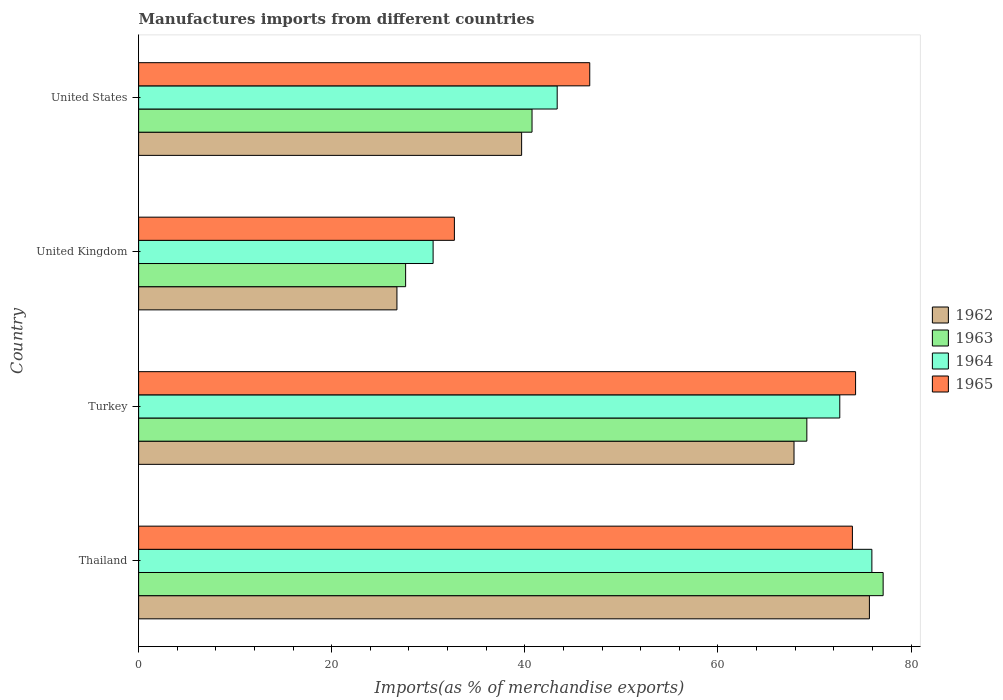How many groups of bars are there?
Your response must be concise. 4. How many bars are there on the 3rd tick from the top?
Provide a short and direct response. 4. In how many cases, is the number of bars for a given country not equal to the number of legend labels?
Keep it short and to the point. 0. What is the percentage of imports to different countries in 1962 in Thailand?
Give a very brief answer. 75.69. Across all countries, what is the maximum percentage of imports to different countries in 1964?
Offer a terse response. 75.95. Across all countries, what is the minimum percentage of imports to different countries in 1965?
Your response must be concise. 32.71. In which country was the percentage of imports to different countries in 1963 maximum?
Ensure brevity in your answer.  Thailand. In which country was the percentage of imports to different countries in 1964 minimum?
Make the answer very short. United Kingdom. What is the total percentage of imports to different countries in 1965 in the graph?
Your answer should be compact. 227.63. What is the difference between the percentage of imports to different countries in 1964 in Turkey and that in United Kingdom?
Your answer should be very brief. 42.12. What is the difference between the percentage of imports to different countries in 1962 in United States and the percentage of imports to different countries in 1963 in United Kingdom?
Your answer should be very brief. 12.01. What is the average percentage of imports to different countries in 1962 per country?
Your response must be concise. 52.5. What is the difference between the percentage of imports to different countries in 1962 and percentage of imports to different countries in 1963 in United Kingdom?
Ensure brevity in your answer.  -0.9. What is the ratio of the percentage of imports to different countries in 1964 in Thailand to that in United States?
Provide a short and direct response. 1.75. Is the difference between the percentage of imports to different countries in 1962 in Turkey and United Kingdom greater than the difference between the percentage of imports to different countries in 1963 in Turkey and United Kingdom?
Provide a succinct answer. No. What is the difference between the highest and the second highest percentage of imports to different countries in 1964?
Provide a succinct answer. 3.33. What is the difference between the highest and the lowest percentage of imports to different countries in 1965?
Provide a succinct answer. 41.55. Is the sum of the percentage of imports to different countries in 1965 in Thailand and United Kingdom greater than the maximum percentage of imports to different countries in 1964 across all countries?
Ensure brevity in your answer.  Yes. What does the 3rd bar from the top in United States represents?
Offer a terse response. 1963. How many countries are there in the graph?
Provide a succinct answer. 4. What is the difference between two consecutive major ticks on the X-axis?
Offer a very short reply. 20. Are the values on the major ticks of X-axis written in scientific E-notation?
Keep it short and to the point. No. Does the graph contain any zero values?
Offer a very short reply. No. How many legend labels are there?
Provide a short and direct response. 4. How are the legend labels stacked?
Offer a terse response. Vertical. What is the title of the graph?
Provide a succinct answer. Manufactures imports from different countries. Does "2004" appear as one of the legend labels in the graph?
Make the answer very short. No. What is the label or title of the X-axis?
Make the answer very short. Imports(as % of merchandise exports). What is the label or title of the Y-axis?
Offer a very short reply. Country. What is the Imports(as % of merchandise exports) of 1962 in Thailand?
Keep it short and to the point. 75.69. What is the Imports(as % of merchandise exports) in 1963 in Thailand?
Make the answer very short. 77.12. What is the Imports(as % of merchandise exports) in 1964 in Thailand?
Ensure brevity in your answer.  75.95. What is the Imports(as % of merchandise exports) in 1965 in Thailand?
Provide a succinct answer. 73.93. What is the Imports(as % of merchandise exports) of 1962 in Turkey?
Make the answer very short. 67.88. What is the Imports(as % of merchandise exports) in 1963 in Turkey?
Offer a very short reply. 69.21. What is the Imports(as % of merchandise exports) of 1964 in Turkey?
Offer a very short reply. 72.62. What is the Imports(as % of merchandise exports) of 1965 in Turkey?
Your response must be concise. 74.26. What is the Imports(as % of merchandise exports) in 1962 in United Kingdom?
Keep it short and to the point. 26.76. What is the Imports(as % of merchandise exports) in 1963 in United Kingdom?
Your answer should be very brief. 27.66. What is the Imports(as % of merchandise exports) of 1964 in United Kingdom?
Your answer should be compact. 30.5. What is the Imports(as % of merchandise exports) of 1965 in United Kingdom?
Offer a very short reply. 32.71. What is the Imports(as % of merchandise exports) in 1962 in United States?
Your answer should be very brief. 39.67. What is the Imports(as % of merchandise exports) of 1963 in United States?
Make the answer very short. 40.75. What is the Imports(as % of merchandise exports) of 1964 in United States?
Your response must be concise. 43.35. What is the Imports(as % of merchandise exports) of 1965 in United States?
Provide a short and direct response. 46.73. Across all countries, what is the maximum Imports(as % of merchandise exports) in 1962?
Your answer should be very brief. 75.69. Across all countries, what is the maximum Imports(as % of merchandise exports) in 1963?
Make the answer very short. 77.12. Across all countries, what is the maximum Imports(as % of merchandise exports) of 1964?
Offer a terse response. 75.95. Across all countries, what is the maximum Imports(as % of merchandise exports) of 1965?
Provide a succinct answer. 74.26. Across all countries, what is the minimum Imports(as % of merchandise exports) of 1962?
Ensure brevity in your answer.  26.76. Across all countries, what is the minimum Imports(as % of merchandise exports) of 1963?
Keep it short and to the point. 27.66. Across all countries, what is the minimum Imports(as % of merchandise exports) of 1964?
Offer a terse response. 30.5. Across all countries, what is the minimum Imports(as % of merchandise exports) of 1965?
Offer a terse response. 32.71. What is the total Imports(as % of merchandise exports) in 1962 in the graph?
Offer a terse response. 210. What is the total Imports(as % of merchandise exports) in 1963 in the graph?
Your response must be concise. 214.73. What is the total Imports(as % of merchandise exports) in 1964 in the graph?
Keep it short and to the point. 222.43. What is the total Imports(as % of merchandise exports) in 1965 in the graph?
Make the answer very short. 227.63. What is the difference between the Imports(as % of merchandise exports) of 1962 in Thailand and that in Turkey?
Your answer should be compact. 7.81. What is the difference between the Imports(as % of merchandise exports) of 1963 in Thailand and that in Turkey?
Your response must be concise. 7.9. What is the difference between the Imports(as % of merchandise exports) of 1964 in Thailand and that in Turkey?
Make the answer very short. 3.33. What is the difference between the Imports(as % of merchandise exports) of 1965 in Thailand and that in Turkey?
Keep it short and to the point. -0.33. What is the difference between the Imports(as % of merchandise exports) of 1962 in Thailand and that in United Kingdom?
Make the answer very short. 48.94. What is the difference between the Imports(as % of merchandise exports) of 1963 in Thailand and that in United Kingdom?
Offer a very short reply. 49.46. What is the difference between the Imports(as % of merchandise exports) of 1964 in Thailand and that in United Kingdom?
Provide a succinct answer. 45.45. What is the difference between the Imports(as % of merchandise exports) in 1965 in Thailand and that in United Kingdom?
Your answer should be compact. 41.22. What is the difference between the Imports(as % of merchandise exports) in 1962 in Thailand and that in United States?
Make the answer very short. 36.02. What is the difference between the Imports(as % of merchandise exports) of 1963 in Thailand and that in United States?
Provide a succinct answer. 36.37. What is the difference between the Imports(as % of merchandise exports) of 1964 in Thailand and that in United States?
Ensure brevity in your answer.  32.6. What is the difference between the Imports(as % of merchandise exports) in 1965 in Thailand and that in United States?
Give a very brief answer. 27.2. What is the difference between the Imports(as % of merchandise exports) in 1962 in Turkey and that in United Kingdom?
Your response must be concise. 41.13. What is the difference between the Imports(as % of merchandise exports) of 1963 in Turkey and that in United Kingdom?
Your answer should be compact. 41.56. What is the difference between the Imports(as % of merchandise exports) in 1964 in Turkey and that in United Kingdom?
Provide a succinct answer. 42.12. What is the difference between the Imports(as % of merchandise exports) of 1965 in Turkey and that in United Kingdom?
Give a very brief answer. 41.55. What is the difference between the Imports(as % of merchandise exports) of 1962 in Turkey and that in United States?
Your answer should be compact. 28.21. What is the difference between the Imports(as % of merchandise exports) of 1963 in Turkey and that in United States?
Offer a terse response. 28.47. What is the difference between the Imports(as % of merchandise exports) in 1964 in Turkey and that in United States?
Make the answer very short. 29.27. What is the difference between the Imports(as % of merchandise exports) of 1965 in Turkey and that in United States?
Make the answer very short. 27.53. What is the difference between the Imports(as % of merchandise exports) of 1962 in United Kingdom and that in United States?
Ensure brevity in your answer.  -12.91. What is the difference between the Imports(as % of merchandise exports) in 1963 in United Kingdom and that in United States?
Make the answer very short. -13.09. What is the difference between the Imports(as % of merchandise exports) in 1964 in United Kingdom and that in United States?
Your answer should be compact. -12.85. What is the difference between the Imports(as % of merchandise exports) of 1965 in United Kingdom and that in United States?
Ensure brevity in your answer.  -14.02. What is the difference between the Imports(as % of merchandise exports) in 1962 in Thailand and the Imports(as % of merchandise exports) in 1963 in Turkey?
Provide a short and direct response. 6.48. What is the difference between the Imports(as % of merchandise exports) in 1962 in Thailand and the Imports(as % of merchandise exports) in 1964 in Turkey?
Your response must be concise. 3.07. What is the difference between the Imports(as % of merchandise exports) in 1962 in Thailand and the Imports(as % of merchandise exports) in 1965 in Turkey?
Provide a short and direct response. 1.43. What is the difference between the Imports(as % of merchandise exports) of 1963 in Thailand and the Imports(as % of merchandise exports) of 1964 in Turkey?
Your response must be concise. 4.49. What is the difference between the Imports(as % of merchandise exports) in 1963 in Thailand and the Imports(as % of merchandise exports) in 1965 in Turkey?
Offer a terse response. 2.85. What is the difference between the Imports(as % of merchandise exports) in 1964 in Thailand and the Imports(as % of merchandise exports) in 1965 in Turkey?
Give a very brief answer. 1.69. What is the difference between the Imports(as % of merchandise exports) in 1962 in Thailand and the Imports(as % of merchandise exports) in 1963 in United Kingdom?
Your answer should be compact. 48.04. What is the difference between the Imports(as % of merchandise exports) of 1962 in Thailand and the Imports(as % of merchandise exports) of 1964 in United Kingdom?
Make the answer very short. 45.19. What is the difference between the Imports(as % of merchandise exports) in 1962 in Thailand and the Imports(as % of merchandise exports) in 1965 in United Kingdom?
Your answer should be very brief. 42.99. What is the difference between the Imports(as % of merchandise exports) of 1963 in Thailand and the Imports(as % of merchandise exports) of 1964 in United Kingdom?
Your answer should be very brief. 46.61. What is the difference between the Imports(as % of merchandise exports) in 1963 in Thailand and the Imports(as % of merchandise exports) in 1965 in United Kingdom?
Give a very brief answer. 44.41. What is the difference between the Imports(as % of merchandise exports) in 1964 in Thailand and the Imports(as % of merchandise exports) in 1965 in United Kingdom?
Your answer should be very brief. 43.24. What is the difference between the Imports(as % of merchandise exports) of 1962 in Thailand and the Imports(as % of merchandise exports) of 1963 in United States?
Ensure brevity in your answer.  34.95. What is the difference between the Imports(as % of merchandise exports) of 1962 in Thailand and the Imports(as % of merchandise exports) of 1964 in United States?
Make the answer very short. 32.34. What is the difference between the Imports(as % of merchandise exports) in 1962 in Thailand and the Imports(as % of merchandise exports) in 1965 in United States?
Offer a terse response. 28.97. What is the difference between the Imports(as % of merchandise exports) in 1963 in Thailand and the Imports(as % of merchandise exports) in 1964 in United States?
Your answer should be very brief. 33.76. What is the difference between the Imports(as % of merchandise exports) in 1963 in Thailand and the Imports(as % of merchandise exports) in 1965 in United States?
Give a very brief answer. 30.39. What is the difference between the Imports(as % of merchandise exports) in 1964 in Thailand and the Imports(as % of merchandise exports) in 1965 in United States?
Provide a short and direct response. 29.22. What is the difference between the Imports(as % of merchandise exports) of 1962 in Turkey and the Imports(as % of merchandise exports) of 1963 in United Kingdom?
Your answer should be very brief. 40.23. What is the difference between the Imports(as % of merchandise exports) of 1962 in Turkey and the Imports(as % of merchandise exports) of 1964 in United Kingdom?
Offer a very short reply. 37.38. What is the difference between the Imports(as % of merchandise exports) in 1962 in Turkey and the Imports(as % of merchandise exports) in 1965 in United Kingdom?
Offer a very short reply. 35.18. What is the difference between the Imports(as % of merchandise exports) of 1963 in Turkey and the Imports(as % of merchandise exports) of 1964 in United Kingdom?
Your answer should be very brief. 38.71. What is the difference between the Imports(as % of merchandise exports) in 1963 in Turkey and the Imports(as % of merchandise exports) in 1965 in United Kingdom?
Provide a succinct answer. 36.51. What is the difference between the Imports(as % of merchandise exports) of 1964 in Turkey and the Imports(as % of merchandise exports) of 1965 in United Kingdom?
Offer a very short reply. 39.92. What is the difference between the Imports(as % of merchandise exports) in 1962 in Turkey and the Imports(as % of merchandise exports) in 1963 in United States?
Offer a very short reply. 27.14. What is the difference between the Imports(as % of merchandise exports) of 1962 in Turkey and the Imports(as % of merchandise exports) of 1964 in United States?
Your response must be concise. 24.53. What is the difference between the Imports(as % of merchandise exports) in 1962 in Turkey and the Imports(as % of merchandise exports) in 1965 in United States?
Your response must be concise. 21.16. What is the difference between the Imports(as % of merchandise exports) of 1963 in Turkey and the Imports(as % of merchandise exports) of 1964 in United States?
Provide a succinct answer. 25.86. What is the difference between the Imports(as % of merchandise exports) in 1963 in Turkey and the Imports(as % of merchandise exports) in 1965 in United States?
Provide a short and direct response. 22.49. What is the difference between the Imports(as % of merchandise exports) of 1964 in Turkey and the Imports(as % of merchandise exports) of 1965 in United States?
Ensure brevity in your answer.  25.9. What is the difference between the Imports(as % of merchandise exports) of 1962 in United Kingdom and the Imports(as % of merchandise exports) of 1963 in United States?
Your response must be concise. -13.99. What is the difference between the Imports(as % of merchandise exports) of 1962 in United Kingdom and the Imports(as % of merchandise exports) of 1964 in United States?
Your answer should be compact. -16.6. What is the difference between the Imports(as % of merchandise exports) of 1962 in United Kingdom and the Imports(as % of merchandise exports) of 1965 in United States?
Keep it short and to the point. -19.97. What is the difference between the Imports(as % of merchandise exports) of 1963 in United Kingdom and the Imports(as % of merchandise exports) of 1964 in United States?
Provide a short and direct response. -15.7. What is the difference between the Imports(as % of merchandise exports) in 1963 in United Kingdom and the Imports(as % of merchandise exports) in 1965 in United States?
Provide a short and direct response. -19.07. What is the difference between the Imports(as % of merchandise exports) in 1964 in United Kingdom and the Imports(as % of merchandise exports) in 1965 in United States?
Provide a short and direct response. -16.22. What is the average Imports(as % of merchandise exports) in 1962 per country?
Ensure brevity in your answer.  52.5. What is the average Imports(as % of merchandise exports) of 1963 per country?
Give a very brief answer. 53.68. What is the average Imports(as % of merchandise exports) of 1964 per country?
Keep it short and to the point. 55.61. What is the average Imports(as % of merchandise exports) of 1965 per country?
Provide a short and direct response. 56.91. What is the difference between the Imports(as % of merchandise exports) of 1962 and Imports(as % of merchandise exports) of 1963 in Thailand?
Offer a terse response. -1.42. What is the difference between the Imports(as % of merchandise exports) of 1962 and Imports(as % of merchandise exports) of 1964 in Thailand?
Offer a very short reply. -0.26. What is the difference between the Imports(as % of merchandise exports) in 1962 and Imports(as % of merchandise exports) in 1965 in Thailand?
Give a very brief answer. 1.76. What is the difference between the Imports(as % of merchandise exports) in 1963 and Imports(as % of merchandise exports) in 1964 in Thailand?
Ensure brevity in your answer.  1.17. What is the difference between the Imports(as % of merchandise exports) of 1963 and Imports(as % of merchandise exports) of 1965 in Thailand?
Your answer should be very brief. 3.18. What is the difference between the Imports(as % of merchandise exports) in 1964 and Imports(as % of merchandise exports) in 1965 in Thailand?
Keep it short and to the point. 2.02. What is the difference between the Imports(as % of merchandise exports) in 1962 and Imports(as % of merchandise exports) in 1963 in Turkey?
Give a very brief answer. -1.33. What is the difference between the Imports(as % of merchandise exports) of 1962 and Imports(as % of merchandise exports) of 1964 in Turkey?
Offer a terse response. -4.74. What is the difference between the Imports(as % of merchandise exports) in 1962 and Imports(as % of merchandise exports) in 1965 in Turkey?
Offer a terse response. -6.38. What is the difference between the Imports(as % of merchandise exports) of 1963 and Imports(as % of merchandise exports) of 1964 in Turkey?
Your answer should be compact. -3.41. What is the difference between the Imports(as % of merchandise exports) in 1963 and Imports(as % of merchandise exports) in 1965 in Turkey?
Your answer should be very brief. -5.05. What is the difference between the Imports(as % of merchandise exports) in 1964 and Imports(as % of merchandise exports) in 1965 in Turkey?
Your answer should be very brief. -1.64. What is the difference between the Imports(as % of merchandise exports) of 1962 and Imports(as % of merchandise exports) of 1963 in United Kingdom?
Give a very brief answer. -0.9. What is the difference between the Imports(as % of merchandise exports) of 1962 and Imports(as % of merchandise exports) of 1964 in United Kingdom?
Provide a short and direct response. -3.75. What is the difference between the Imports(as % of merchandise exports) of 1962 and Imports(as % of merchandise exports) of 1965 in United Kingdom?
Give a very brief answer. -5.95. What is the difference between the Imports(as % of merchandise exports) of 1963 and Imports(as % of merchandise exports) of 1964 in United Kingdom?
Make the answer very short. -2.85. What is the difference between the Imports(as % of merchandise exports) in 1963 and Imports(as % of merchandise exports) in 1965 in United Kingdom?
Make the answer very short. -5.05. What is the difference between the Imports(as % of merchandise exports) of 1964 and Imports(as % of merchandise exports) of 1965 in United Kingdom?
Your answer should be very brief. -2.2. What is the difference between the Imports(as % of merchandise exports) of 1962 and Imports(as % of merchandise exports) of 1963 in United States?
Keep it short and to the point. -1.08. What is the difference between the Imports(as % of merchandise exports) in 1962 and Imports(as % of merchandise exports) in 1964 in United States?
Give a very brief answer. -3.68. What is the difference between the Imports(as % of merchandise exports) in 1962 and Imports(as % of merchandise exports) in 1965 in United States?
Your answer should be compact. -7.06. What is the difference between the Imports(as % of merchandise exports) in 1963 and Imports(as % of merchandise exports) in 1964 in United States?
Your response must be concise. -2.61. What is the difference between the Imports(as % of merchandise exports) of 1963 and Imports(as % of merchandise exports) of 1965 in United States?
Provide a succinct answer. -5.98. What is the difference between the Imports(as % of merchandise exports) in 1964 and Imports(as % of merchandise exports) in 1965 in United States?
Provide a short and direct response. -3.37. What is the ratio of the Imports(as % of merchandise exports) of 1962 in Thailand to that in Turkey?
Your response must be concise. 1.11. What is the ratio of the Imports(as % of merchandise exports) in 1963 in Thailand to that in Turkey?
Make the answer very short. 1.11. What is the ratio of the Imports(as % of merchandise exports) in 1964 in Thailand to that in Turkey?
Ensure brevity in your answer.  1.05. What is the ratio of the Imports(as % of merchandise exports) in 1965 in Thailand to that in Turkey?
Make the answer very short. 1. What is the ratio of the Imports(as % of merchandise exports) in 1962 in Thailand to that in United Kingdom?
Ensure brevity in your answer.  2.83. What is the ratio of the Imports(as % of merchandise exports) of 1963 in Thailand to that in United Kingdom?
Give a very brief answer. 2.79. What is the ratio of the Imports(as % of merchandise exports) in 1964 in Thailand to that in United Kingdom?
Provide a short and direct response. 2.49. What is the ratio of the Imports(as % of merchandise exports) of 1965 in Thailand to that in United Kingdom?
Offer a terse response. 2.26. What is the ratio of the Imports(as % of merchandise exports) of 1962 in Thailand to that in United States?
Provide a succinct answer. 1.91. What is the ratio of the Imports(as % of merchandise exports) in 1963 in Thailand to that in United States?
Provide a succinct answer. 1.89. What is the ratio of the Imports(as % of merchandise exports) of 1964 in Thailand to that in United States?
Give a very brief answer. 1.75. What is the ratio of the Imports(as % of merchandise exports) of 1965 in Thailand to that in United States?
Your answer should be very brief. 1.58. What is the ratio of the Imports(as % of merchandise exports) in 1962 in Turkey to that in United Kingdom?
Your response must be concise. 2.54. What is the ratio of the Imports(as % of merchandise exports) in 1963 in Turkey to that in United Kingdom?
Provide a short and direct response. 2.5. What is the ratio of the Imports(as % of merchandise exports) of 1964 in Turkey to that in United Kingdom?
Provide a succinct answer. 2.38. What is the ratio of the Imports(as % of merchandise exports) in 1965 in Turkey to that in United Kingdom?
Provide a short and direct response. 2.27. What is the ratio of the Imports(as % of merchandise exports) in 1962 in Turkey to that in United States?
Make the answer very short. 1.71. What is the ratio of the Imports(as % of merchandise exports) in 1963 in Turkey to that in United States?
Keep it short and to the point. 1.7. What is the ratio of the Imports(as % of merchandise exports) of 1964 in Turkey to that in United States?
Give a very brief answer. 1.68. What is the ratio of the Imports(as % of merchandise exports) of 1965 in Turkey to that in United States?
Offer a very short reply. 1.59. What is the ratio of the Imports(as % of merchandise exports) of 1962 in United Kingdom to that in United States?
Provide a succinct answer. 0.67. What is the ratio of the Imports(as % of merchandise exports) in 1963 in United Kingdom to that in United States?
Offer a very short reply. 0.68. What is the ratio of the Imports(as % of merchandise exports) in 1964 in United Kingdom to that in United States?
Your response must be concise. 0.7. What is the difference between the highest and the second highest Imports(as % of merchandise exports) in 1962?
Keep it short and to the point. 7.81. What is the difference between the highest and the second highest Imports(as % of merchandise exports) in 1963?
Make the answer very short. 7.9. What is the difference between the highest and the second highest Imports(as % of merchandise exports) in 1964?
Give a very brief answer. 3.33. What is the difference between the highest and the second highest Imports(as % of merchandise exports) of 1965?
Make the answer very short. 0.33. What is the difference between the highest and the lowest Imports(as % of merchandise exports) in 1962?
Ensure brevity in your answer.  48.94. What is the difference between the highest and the lowest Imports(as % of merchandise exports) in 1963?
Offer a very short reply. 49.46. What is the difference between the highest and the lowest Imports(as % of merchandise exports) of 1964?
Provide a short and direct response. 45.45. What is the difference between the highest and the lowest Imports(as % of merchandise exports) in 1965?
Your answer should be compact. 41.55. 